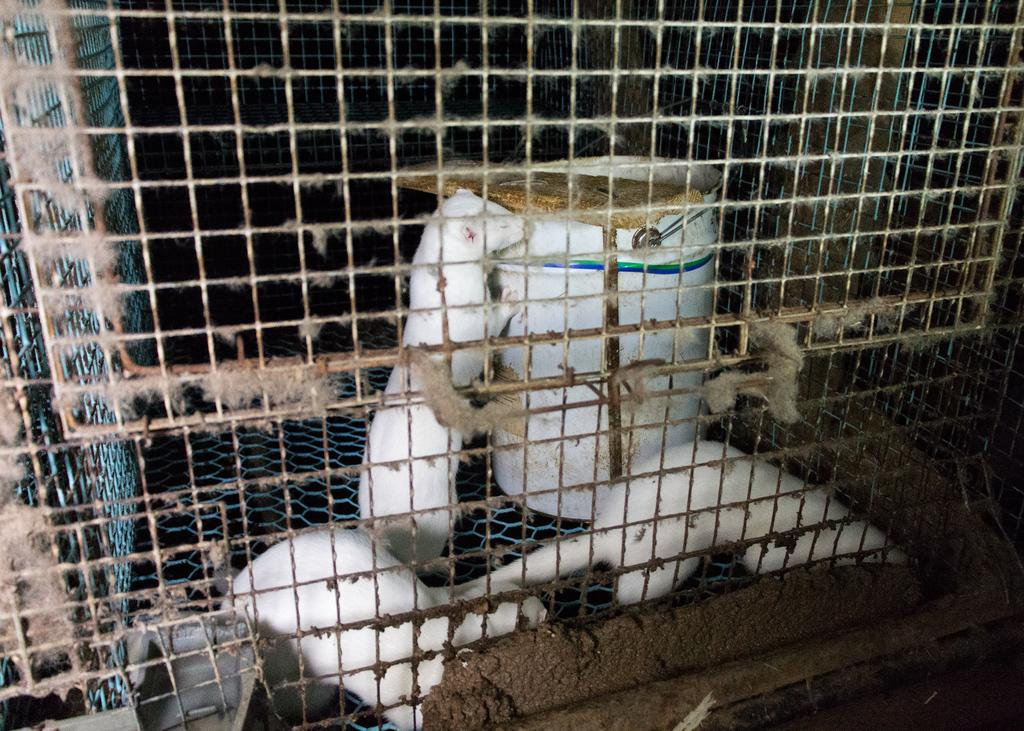What is inside the cage that is visible in the image? There are animals in a cage in the image. What other object can be seen in the image? There is a bucket in the image. What type of rose is being discussed by the animals in the image? There is no rose present in the image, nor is there any discussion among the animals. 